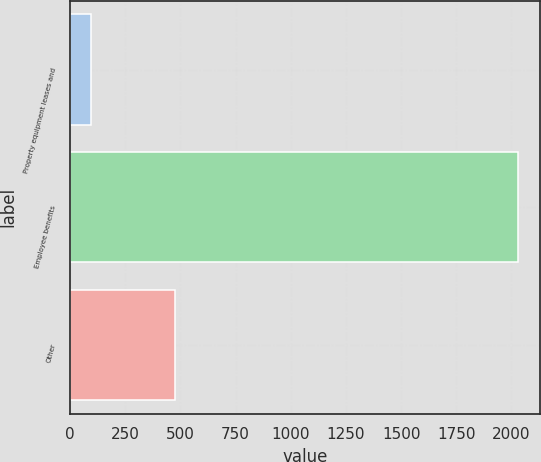<chart> <loc_0><loc_0><loc_500><loc_500><bar_chart><fcel>Property equipment leases and<fcel>Employee benefits<fcel>Other<nl><fcel>93<fcel>2029<fcel>477<nl></chart> 